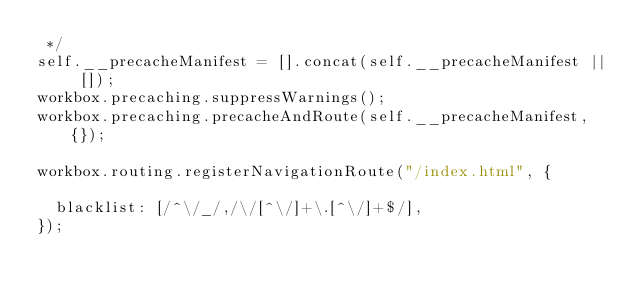<code> <loc_0><loc_0><loc_500><loc_500><_JavaScript_> */
self.__precacheManifest = [].concat(self.__precacheManifest || []);
workbox.precaching.suppressWarnings();
workbox.precaching.precacheAndRoute(self.__precacheManifest, {});

workbox.routing.registerNavigationRoute("/index.html", {
  
  blacklist: [/^\/_/,/\/[^\/]+\.[^\/]+$/],
});
</code> 